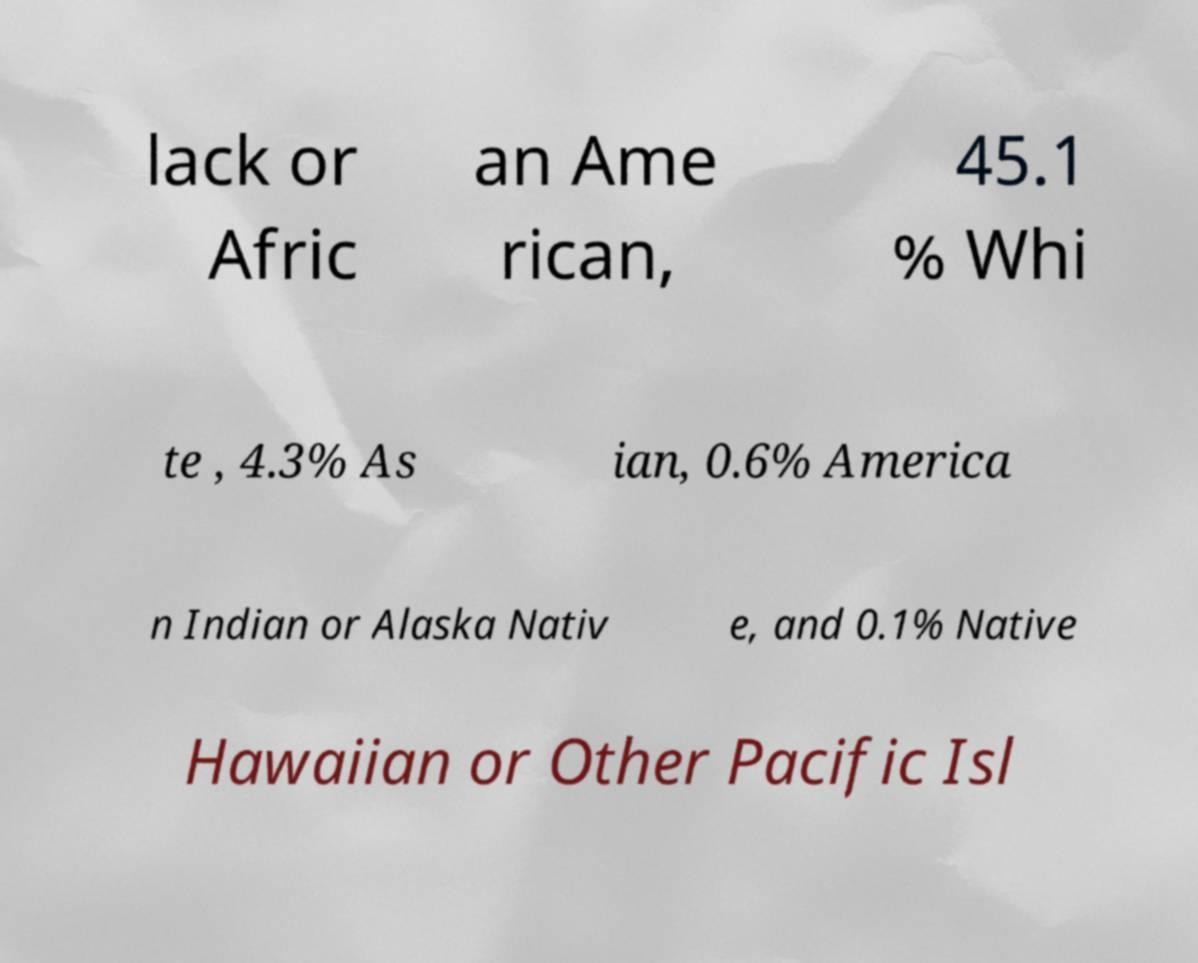Please read and relay the text visible in this image. What does it say? lack or Afric an Ame rican, 45.1 % Whi te , 4.3% As ian, 0.6% America n Indian or Alaska Nativ e, and 0.1% Native Hawaiian or Other Pacific Isl 